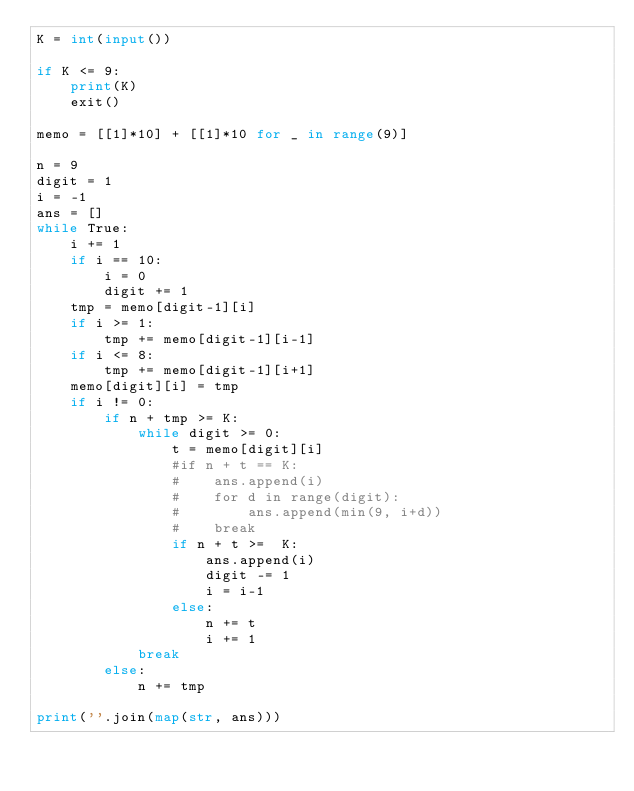<code> <loc_0><loc_0><loc_500><loc_500><_Python_>K = int(input())

if K <= 9:
    print(K)
    exit()

memo = [[1]*10] + [[1]*10 for _ in range(9)]

n = 9
digit = 1
i = -1
ans = []
while True:
    i += 1
    if i == 10:
        i = 0
        digit += 1
    tmp = memo[digit-1][i]
    if i >= 1:
        tmp += memo[digit-1][i-1]
    if i <= 8:
        tmp += memo[digit-1][i+1]
    memo[digit][i] = tmp
    if i != 0:
        if n + tmp >= K:
            while digit >= 0:
                t = memo[digit][i]
                #if n + t == K:
                #    ans.append(i)
                #    for d in range(digit):
                #        ans.append(min(9, i+d))
                #    break
                if n + t >=  K:
                    ans.append(i)
                    digit -= 1
                    i = i-1
                else:
                    n += t
                    i += 1
            break
        else:
            n += tmp

print(''.join(map(str, ans)))</code> 